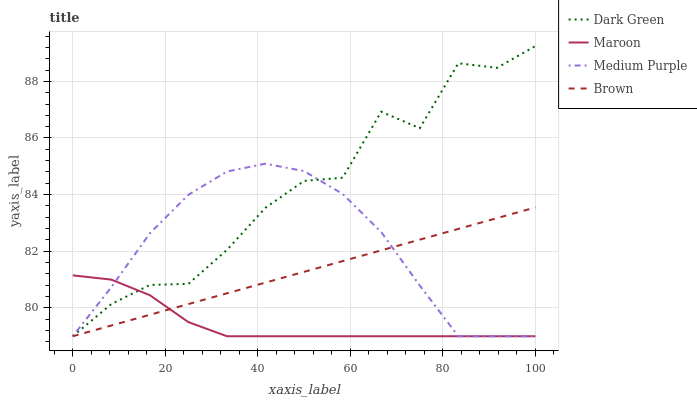Does Maroon have the minimum area under the curve?
Answer yes or no. Yes. Does Dark Green have the maximum area under the curve?
Answer yes or no. Yes. Does Brown have the minimum area under the curve?
Answer yes or no. No. Does Brown have the maximum area under the curve?
Answer yes or no. No. Is Brown the smoothest?
Answer yes or no. Yes. Is Dark Green the roughest?
Answer yes or no. Yes. Is Maroon the smoothest?
Answer yes or no. No. Is Maroon the roughest?
Answer yes or no. No. Does Medium Purple have the lowest value?
Answer yes or no. Yes. Does Dark Green have the highest value?
Answer yes or no. Yes. Does Brown have the highest value?
Answer yes or no. No. Does Maroon intersect Dark Green?
Answer yes or no. Yes. Is Maroon less than Dark Green?
Answer yes or no. No. Is Maroon greater than Dark Green?
Answer yes or no. No. 